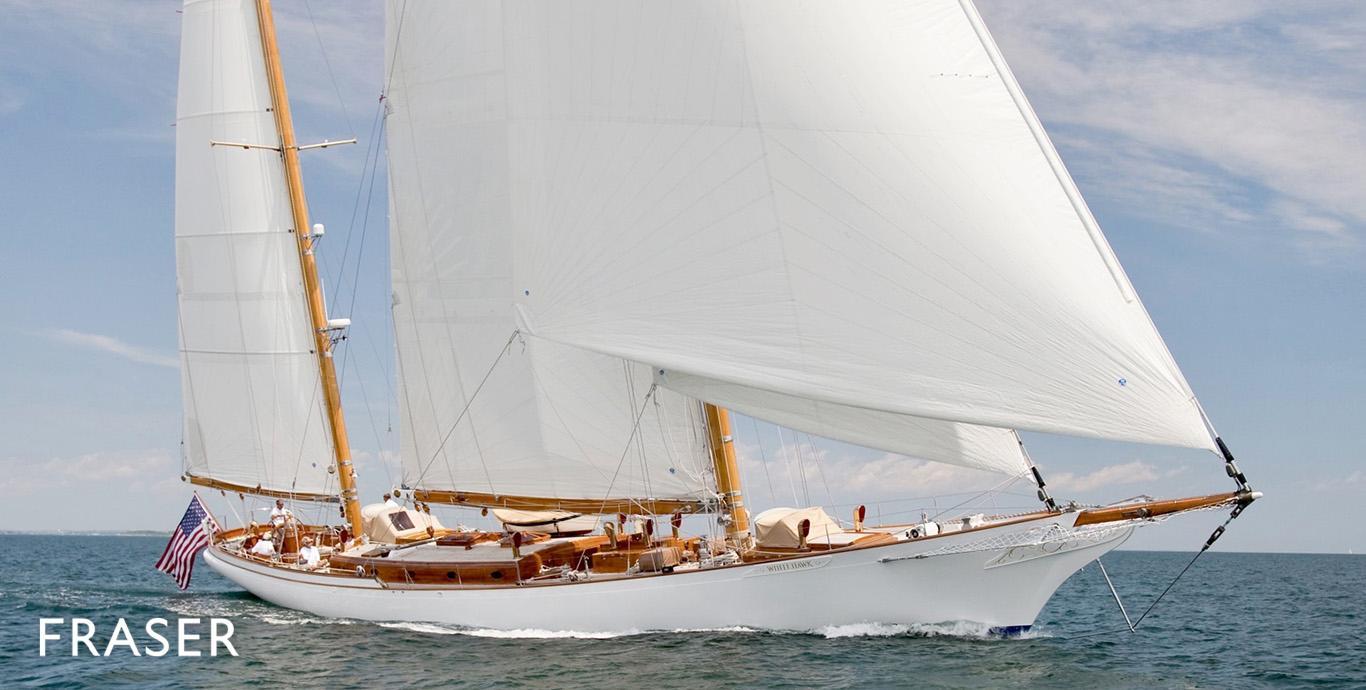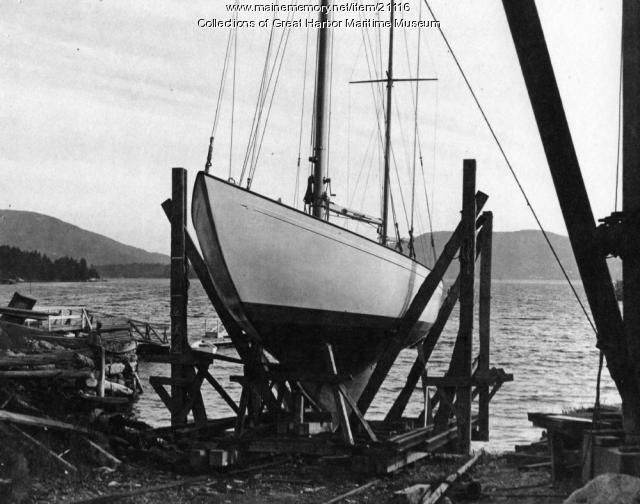The first image is the image on the left, the second image is the image on the right. Given the left and right images, does the statement "The left and right image contains the same number sailboats with open sails." hold true? Answer yes or no. No. The first image is the image on the left, the second image is the image on the right. Assess this claim about the two images: "Two boats are sailing.". Correct or not? Answer yes or no. No. 